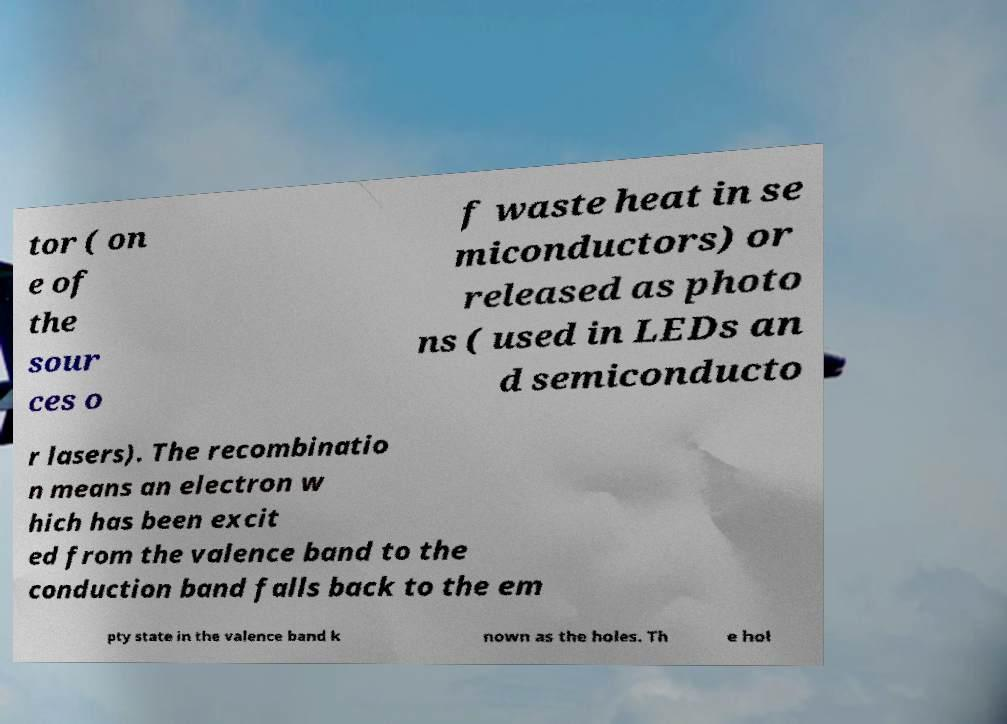Could you extract and type out the text from this image? tor ( on e of the sour ces o f waste heat in se miconductors) or released as photo ns ( used in LEDs an d semiconducto r lasers). The recombinatio n means an electron w hich has been excit ed from the valence band to the conduction band falls back to the em pty state in the valence band k nown as the holes. Th e hol 